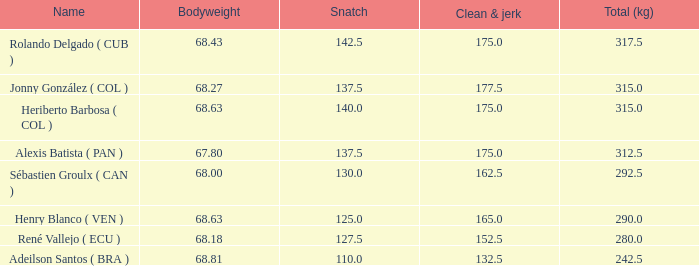Tell me the highest snatch for 68.63 bodyweight and total kg less than 290 None. Would you mind parsing the complete table? {'header': ['Name', 'Bodyweight', 'Snatch', 'Clean & jerk', 'Total (kg)'], 'rows': [['Rolando Delgado ( CUB )', '68.43', '142.5', '175.0', '317.5'], ['Jonny González ( COL )', '68.27', '137.5', '177.5', '315.0'], ['Heriberto Barbosa ( COL )', '68.63', '140.0', '175.0', '315.0'], ['Alexis Batista ( PAN )', '67.80', '137.5', '175.0', '312.5'], ['Sébastien Groulx ( CAN )', '68.00', '130.0', '162.5', '292.5'], ['Henry Blanco ( VEN )', '68.63', '125.0', '165.0', '290.0'], ['René Vallejo ( ECU )', '68.18', '127.5', '152.5', '280.0'], ['Adeilson Santos ( BRA )', '68.81', '110.0', '132.5', '242.5']]} 